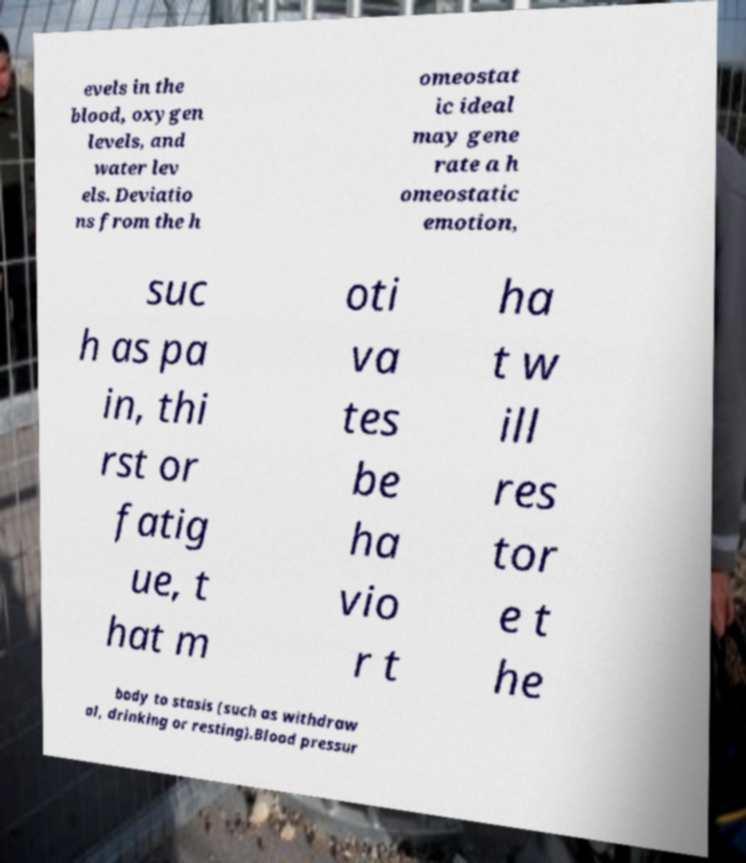Please read and relay the text visible in this image. What does it say? evels in the blood, oxygen levels, and water lev els. Deviatio ns from the h omeostat ic ideal may gene rate a h omeostatic emotion, suc h as pa in, thi rst or fatig ue, t hat m oti va tes be ha vio r t ha t w ill res tor e t he body to stasis (such as withdraw al, drinking or resting).Blood pressur 